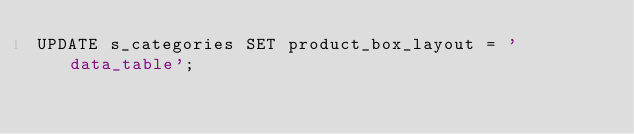<code> <loc_0><loc_0><loc_500><loc_500><_SQL_>UPDATE s_categories SET product_box_layout = 'data_table';
</code> 